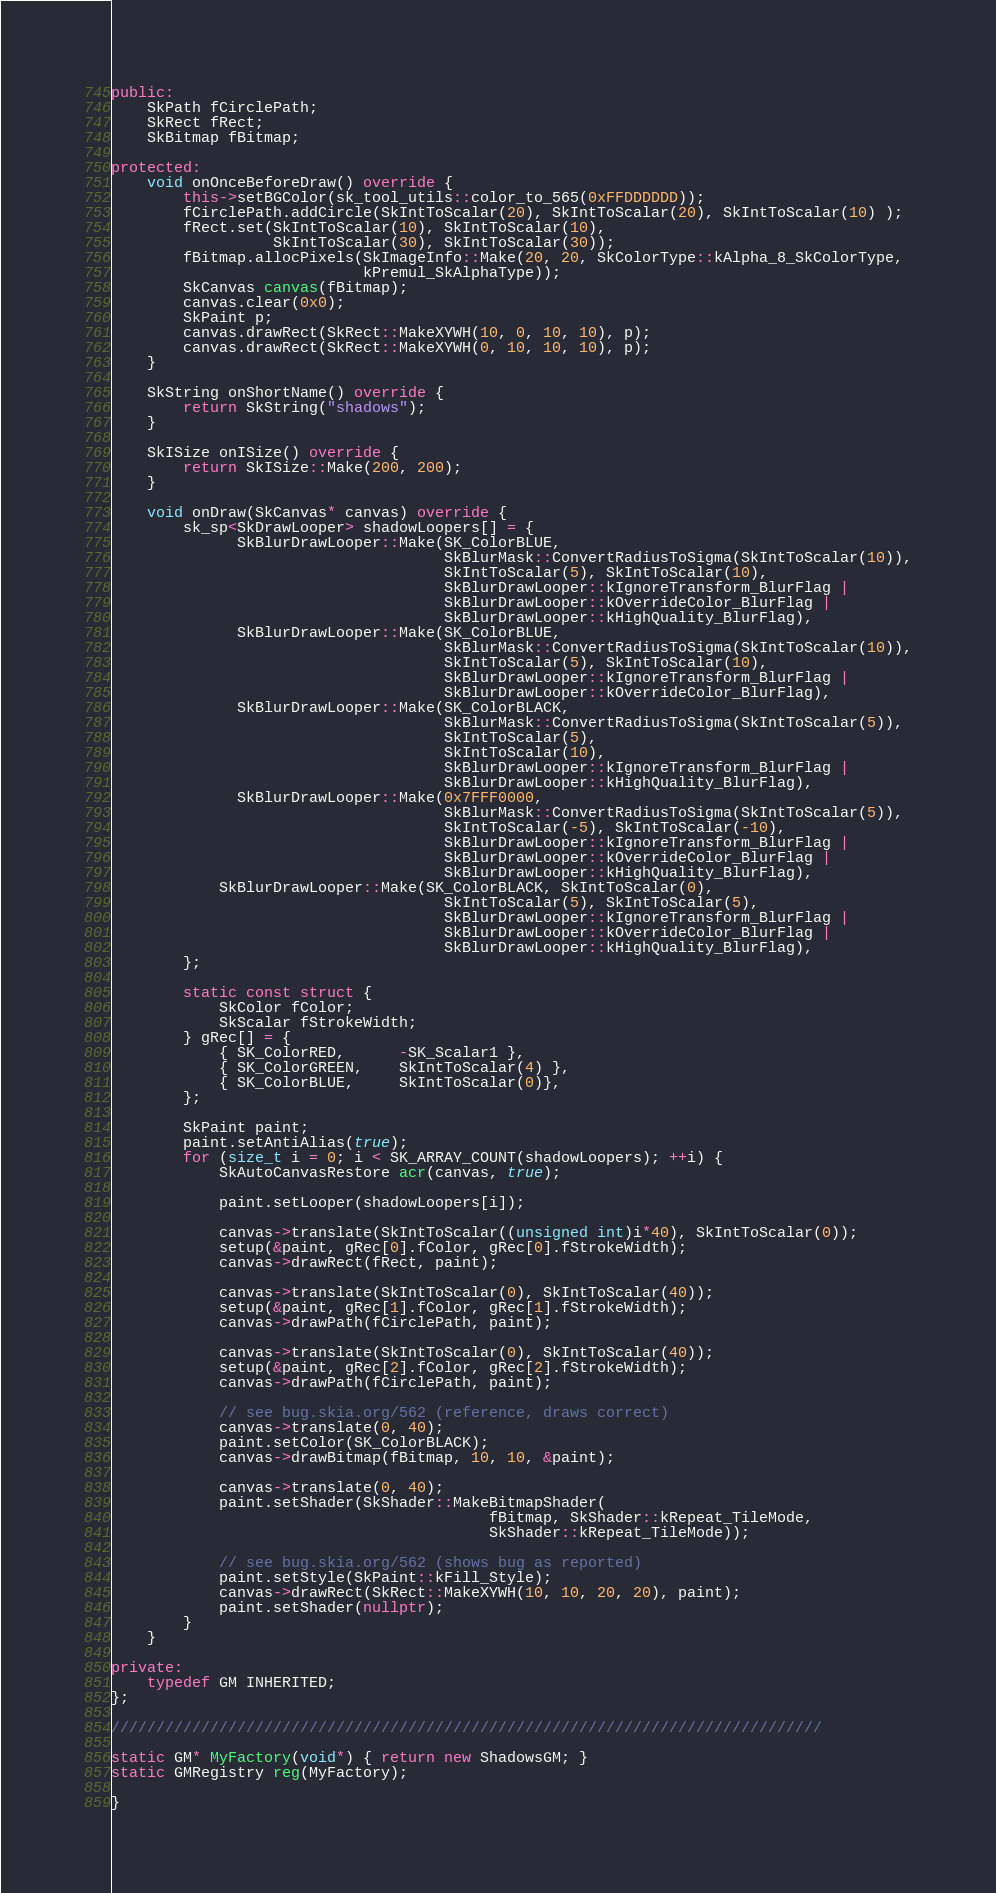<code> <loc_0><loc_0><loc_500><loc_500><_C++_>public:
    SkPath fCirclePath;
    SkRect fRect;
    SkBitmap fBitmap;

protected:
    void onOnceBeforeDraw() override {
        this->setBGColor(sk_tool_utils::color_to_565(0xFFDDDDDD));
        fCirclePath.addCircle(SkIntToScalar(20), SkIntToScalar(20), SkIntToScalar(10) );
        fRect.set(SkIntToScalar(10), SkIntToScalar(10),
                  SkIntToScalar(30), SkIntToScalar(30));
        fBitmap.allocPixels(SkImageInfo::Make(20, 20, SkColorType::kAlpha_8_SkColorType,
                            kPremul_SkAlphaType));
        SkCanvas canvas(fBitmap);
        canvas.clear(0x0);
        SkPaint p;
        canvas.drawRect(SkRect::MakeXYWH(10, 0, 10, 10), p);
        canvas.drawRect(SkRect::MakeXYWH(0, 10, 10, 10), p);
    }

    SkString onShortName() override {
        return SkString("shadows");
    }

    SkISize onISize() override {
        return SkISize::Make(200, 200);
    }

    void onDraw(SkCanvas* canvas) override {
        sk_sp<SkDrawLooper> shadowLoopers[] = {
              SkBlurDrawLooper::Make(SK_ColorBLUE,
                                     SkBlurMask::ConvertRadiusToSigma(SkIntToScalar(10)),
                                     SkIntToScalar(5), SkIntToScalar(10),
                                     SkBlurDrawLooper::kIgnoreTransform_BlurFlag |
                                     SkBlurDrawLooper::kOverrideColor_BlurFlag |
                                     SkBlurDrawLooper::kHighQuality_BlurFlag),
              SkBlurDrawLooper::Make(SK_ColorBLUE,
                                     SkBlurMask::ConvertRadiusToSigma(SkIntToScalar(10)),
                                     SkIntToScalar(5), SkIntToScalar(10),
                                     SkBlurDrawLooper::kIgnoreTransform_BlurFlag |
                                     SkBlurDrawLooper::kOverrideColor_BlurFlag),
              SkBlurDrawLooper::Make(SK_ColorBLACK,
                                     SkBlurMask::ConvertRadiusToSigma(SkIntToScalar(5)),
                                     SkIntToScalar(5),
                                     SkIntToScalar(10),
                                     SkBlurDrawLooper::kIgnoreTransform_BlurFlag |
                                     SkBlurDrawLooper::kHighQuality_BlurFlag),
              SkBlurDrawLooper::Make(0x7FFF0000,
                                     SkBlurMask::ConvertRadiusToSigma(SkIntToScalar(5)),
                                     SkIntToScalar(-5), SkIntToScalar(-10),
                                     SkBlurDrawLooper::kIgnoreTransform_BlurFlag |
                                     SkBlurDrawLooper::kOverrideColor_BlurFlag |
                                     SkBlurDrawLooper::kHighQuality_BlurFlag),
            SkBlurDrawLooper::Make(SK_ColorBLACK, SkIntToScalar(0),
                                     SkIntToScalar(5), SkIntToScalar(5),
                                     SkBlurDrawLooper::kIgnoreTransform_BlurFlag |
                                     SkBlurDrawLooper::kOverrideColor_BlurFlag |
                                     SkBlurDrawLooper::kHighQuality_BlurFlag),
        };

        static const struct {
            SkColor fColor;
            SkScalar fStrokeWidth;
        } gRec[] = {
            { SK_ColorRED,      -SK_Scalar1 },
            { SK_ColorGREEN,    SkIntToScalar(4) },
            { SK_ColorBLUE,     SkIntToScalar(0)},
        };

        SkPaint paint;
        paint.setAntiAlias(true);
        for (size_t i = 0; i < SK_ARRAY_COUNT(shadowLoopers); ++i) {
            SkAutoCanvasRestore acr(canvas, true);

            paint.setLooper(shadowLoopers[i]);

            canvas->translate(SkIntToScalar((unsigned int)i*40), SkIntToScalar(0));
            setup(&paint, gRec[0].fColor, gRec[0].fStrokeWidth);
            canvas->drawRect(fRect, paint);

            canvas->translate(SkIntToScalar(0), SkIntToScalar(40));
            setup(&paint, gRec[1].fColor, gRec[1].fStrokeWidth);
            canvas->drawPath(fCirclePath, paint);

            canvas->translate(SkIntToScalar(0), SkIntToScalar(40));
            setup(&paint, gRec[2].fColor, gRec[2].fStrokeWidth);
            canvas->drawPath(fCirclePath, paint);

            // see bug.skia.org/562 (reference, draws correct)
            canvas->translate(0, 40);
            paint.setColor(SK_ColorBLACK);
            canvas->drawBitmap(fBitmap, 10, 10, &paint);

            canvas->translate(0, 40);
            paint.setShader(SkShader::MakeBitmapShader(
                                          fBitmap, SkShader::kRepeat_TileMode,
                                          SkShader::kRepeat_TileMode));

            // see bug.skia.org/562 (shows bug as reported)
            paint.setStyle(SkPaint::kFill_Style);
            canvas->drawRect(SkRect::MakeXYWH(10, 10, 20, 20), paint);
            paint.setShader(nullptr);
        }
    }

private:
    typedef GM INHERITED;
};

///////////////////////////////////////////////////////////////////////////////

static GM* MyFactory(void*) { return new ShadowsGM; }
static GMRegistry reg(MyFactory);

}
</code> 